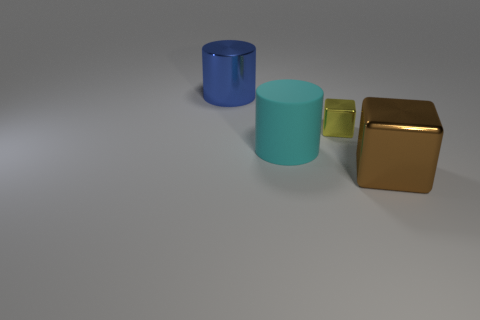Subtract all purple cylinders. Subtract all blue cubes. How many cylinders are left? 2 Add 1 big blue things. How many objects exist? 5 Add 2 big brown things. How many big brown things exist? 3 Subtract 0 cyan spheres. How many objects are left? 4 Subtract all large yellow objects. Subtract all big rubber objects. How many objects are left? 3 Add 1 cyan matte objects. How many cyan matte objects are left? 2 